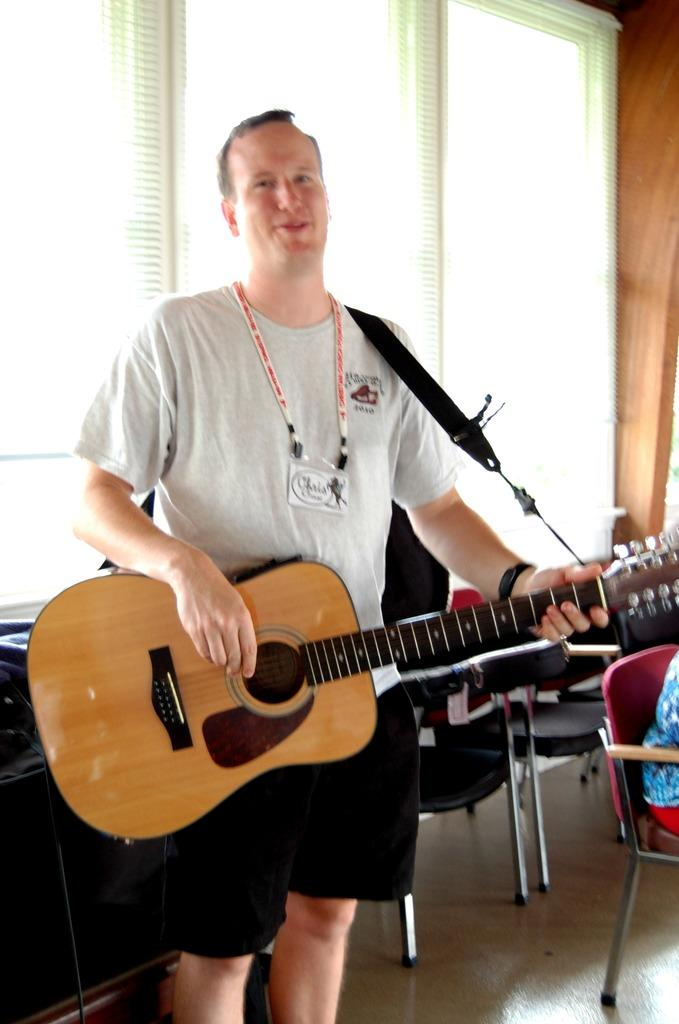What is the man in the image wearing on his upper body? The man is wearing a t-shirt. Does the man have any identification visible in the image? Yes, the man is wearing an ID card. What is the man doing in the image? The man is playing a guitar. What can be seen in the background of the image? There are chairs, a window, and a table in the background. Can you describe the person sitting on a chair in the image? A person is sitting on a red chair. What type of jelly is being used as a guitar pick in the image? There is no jelly present in the image, and the man is not using any jelly as a guitar pick. 